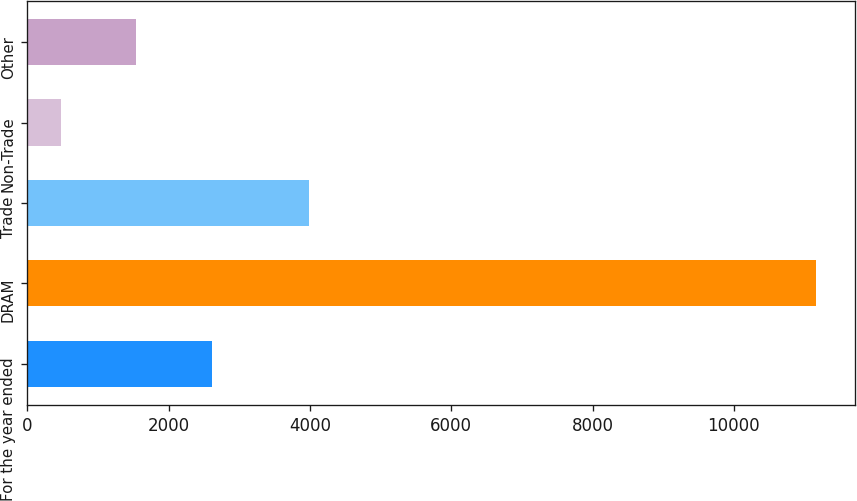<chart> <loc_0><loc_0><loc_500><loc_500><bar_chart><fcel>For the year ended<fcel>DRAM<fcel>Trade<fcel>Non-Trade<fcel>Other<nl><fcel>2612.8<fcel>11164<fcel>3993<fcel>475<fcel>1543.9<nl></chart> 